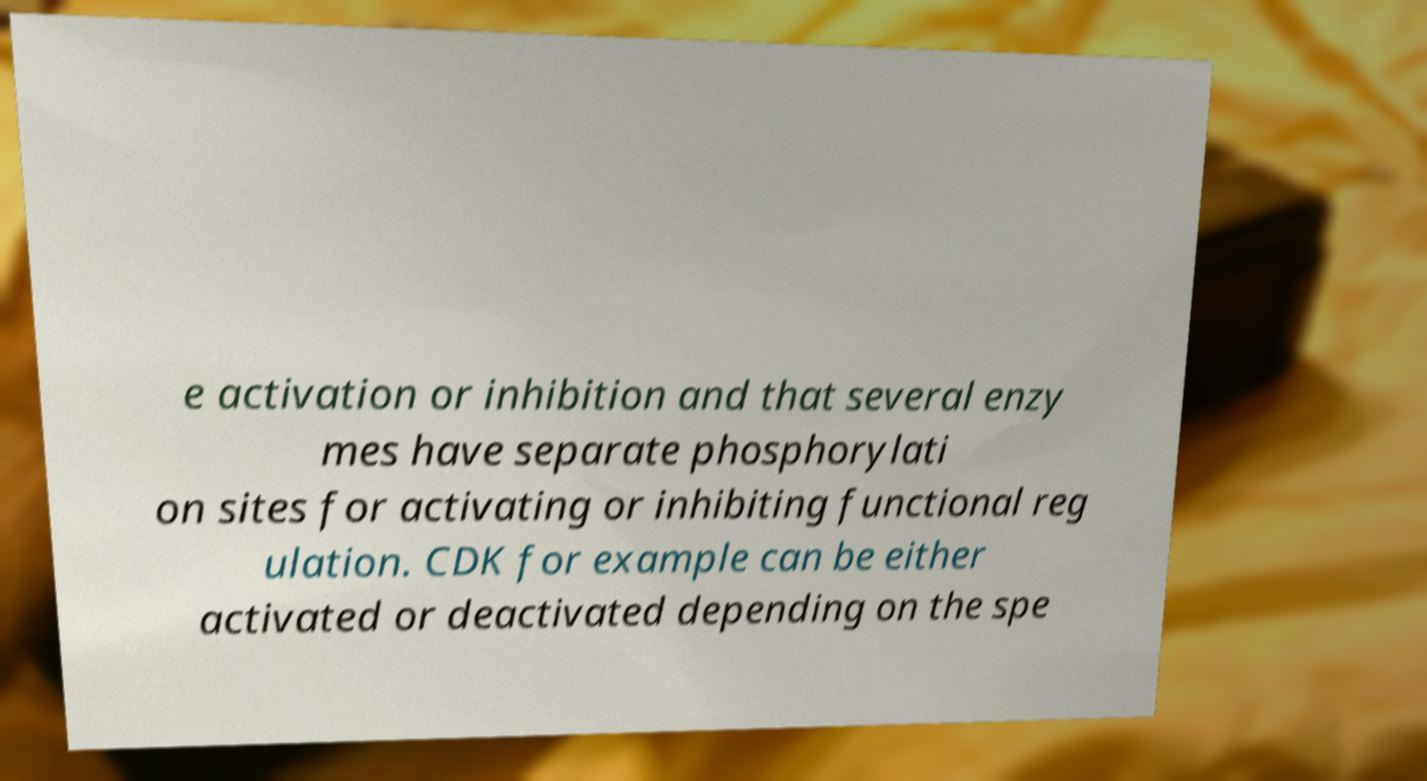Please read and relay the text visible in this image. What does it say? e activation or inhibition and that several enzy mes have separate phosphorylati on sites for activating or inhibiting functional reg ulation. CDK for example can be either activated or deactivated depending on the spe 